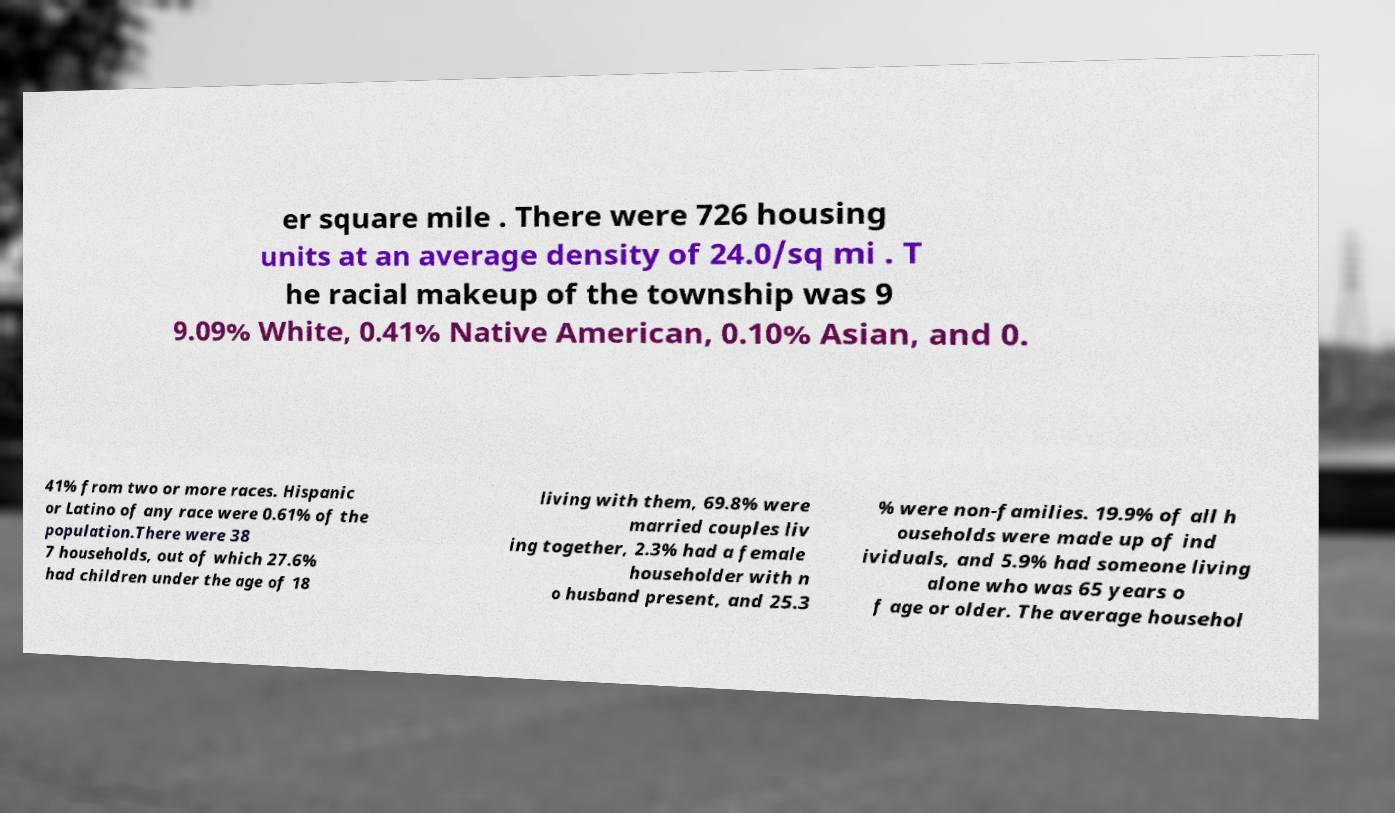Can you read and provide the text displayed in the image?This photo seems to have some interesting text. Can you extract and type it out for me? er square mile . There were 726 housing units at an average density of 24.0/sq mi . T he racial makeup of the township was 9 9.09% White, 0.41% Native American, 0.10% Asian, and 0. 41% from two or more races. Hispanic or Latino of any race were 0.61% of the population.There were 38 7 households, out of which 27.6% had children under the age of 18 living with them, 69.8% were married couples liv ing together, 2.3% had a female householder with n o husband present, and 25.3 % were non-families. 19.9% of all h ouseholds were made up of ind ividuals, and 5.9% had someone living alone who was 65 years o f age or older. The average househol 